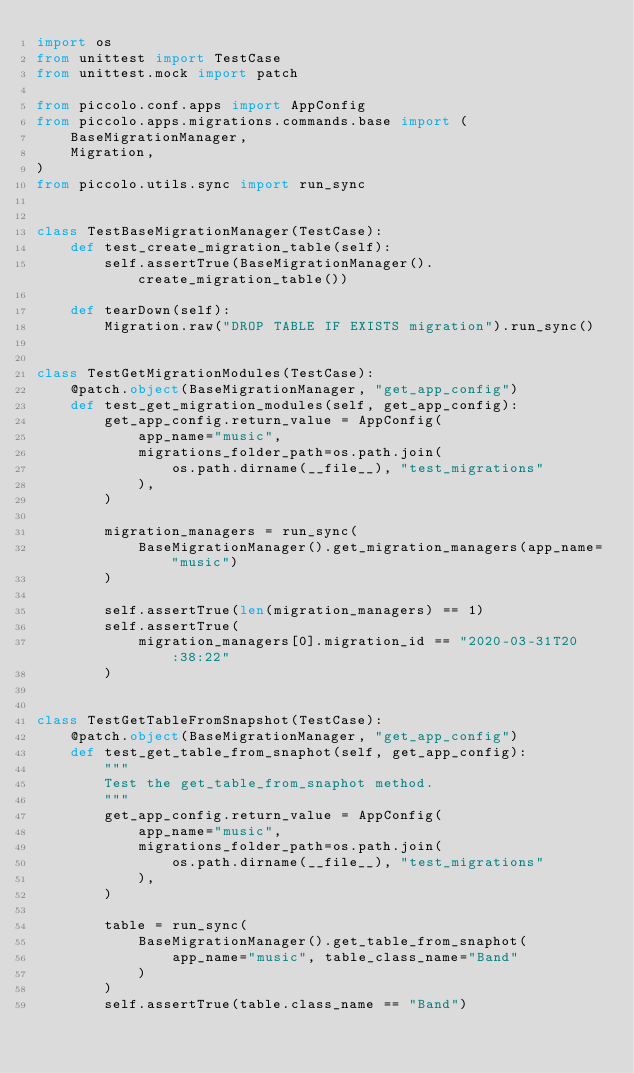Convert code to text. <code><loc_0><loc_0><loc_500><loc_500><_Python_>import os
from unittest import TestCase
from unittest.mock import patch

from piccolo.conf.apps import AppConfig
from piccolo.apps.migrations.commands.base import (
    BaseMigrationManager,
    Migration,
)
from piccolo.utils.sync import run_sync


class TestBaseMigrationManager(TestCase):
    def test_create_migration_table(self):
        self.assertTrue(BaseMigrationManager().create_migration_table())

    def tearDown(self):
        Migration.raw("DROP TABLE IF EXISTS migration").run_sync()


class TestGetMigrationModules(TestCase):
    @patch.object(BaseMigrationManager, "get_app_config")
    def test_get_migration_modules(self, get_app_config):
        get_app_config.return_value = AppConfig(
            app_name="music",
            migrations_folder_path=os.path.join(
                os.path.dirname(__file__), "test_migrations"
            ),
        )

        migration_managers = run_sync(
            BaseMigrationManager().get_migration_managers(app_name="music")
        )

        self.assertTrue(len(migration_managers) == 1)
        self.assertTrue(
            migration_managers[0].migration_id == "2020-03-31T20:38:22"
        )


class TestGetTableFromSnapshot(TestCase):
    @patch.object(BaseMigrationManager, "get_app_config")
    def test_get_table_from_snaphot(self, get_app_config):
        """
        Test the get_table_from_snaphot method.
        """
        get_app_config.return_value = AppConfig(
            app_name="music",
            migrations_folder_path=os.path.join(
                os.path.dirname(__file__), "test_migrations"
            ),
        )

        table = run_sync(
            BaseMigrationManager().get_table_from_snaphot(
                app_name="music", table_class_name="Band"
            )
        )
        self.assertTrue(table.class_name == "Band")
</code> 